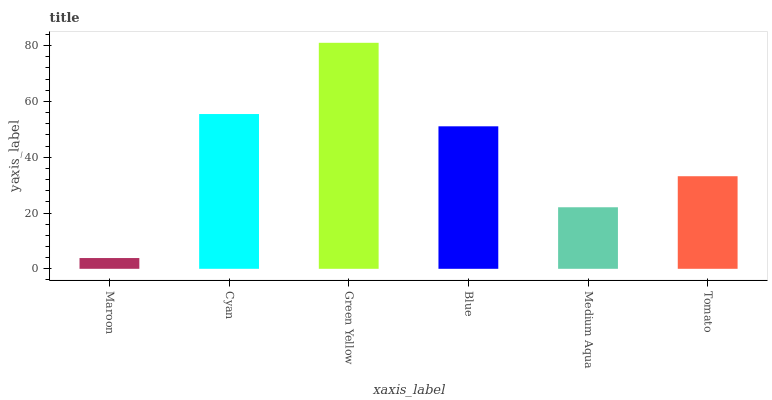Is Maroon the minimum?
Answer yes or no. Yes. Is Green Yellow the maximum?
Answer yes or no. Yes. Is Cyan the minimum?
Answer yes or no. No. Is Cyan the maximum?
Answer yes or no. No. Is Cyan greater than Maroon?
Answer yes or no. Yes. Is Maroon less than Cyan?
Answer yes or no. Yes. Is Maroon greater than Cyan?
Answer yes or no. No. Is Cyan less than Maroon?
Answer yes or no. No. Is Blue the high median?
Answer yes or no. Yes. Is Tomato the low median?
Answer yes or no. Yes. Is Maroon the high median?
Answer yes or no. No. Is Blue the low median?
Answer yes or no. No. 